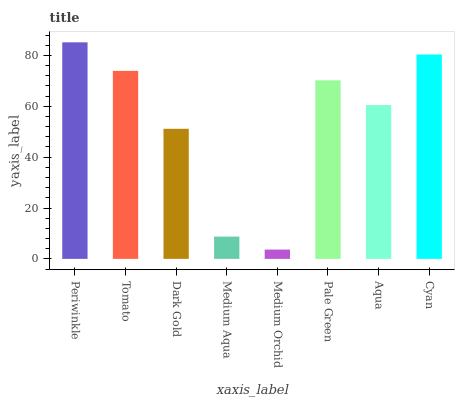Is Medium Orchid the minimum?
Answer yes or no. Yes. Is Periwinkle the maximum?
Answer yes or no. Yes. Is Tomato the minimum?
Answer yes or no. No. Is Tomato the maximum?
Answer yes or no. No. Is Periwinkle greater than Tomato?
Answer yes or no. Yes. Is Tomato less than Periwinkle?
Answer yes or no. Yes. Is Tomato greater than Periwinkle?
Answer yes or no. No. Is Periwinkle less than Tomato?
Answer yes or no. No. Is Pale Green the high median?
Answer yes or no. Yes. Is Aqua the low median?
Answer yes or no. Yes. Is Cyan the high median?
Answer yes or no. No. Is Pale Green the low median?
Answer yes or no. No. 